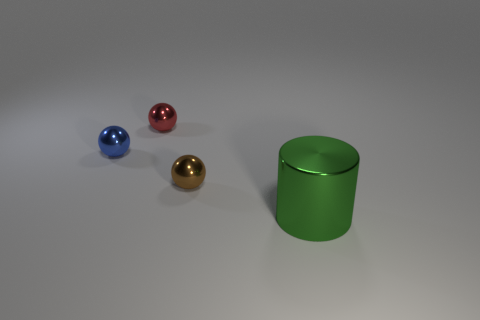What number of tiny shiny things are on the left side of the small shiny ball in front of the tiny blue ball?
Offer a terse response. 2. Are there fewer tiny brown metal objects that are in front of the tiny blue metallic object than tiny red objects that are left of the green cylinder?
Make the answer very short. No. What is the tiny ball that is right of the small red object made of?
Keep it short and to the point. Metal. The tiny sphere that is both on the right side of the tiny blue object and behind the brown object is what color?
Offer a very short reply. Red. What number of other things are the same color as the metallic cylinder?
Provide a succinct answer. 0. There is a thing to the right of the brown thing; what is its color?
Give a very brief answer. Green. Is there another red thing of the same size as the red thing?
Your answer should be very brief. No. What number of objects are small balls that are to the left of the small red metal sphere or things to the left of the shiny cylinder?
Keep it short and to the point. 3. Are there any other tiny shiny things that have the same shape as the brown metal thing?
Keep it short and to the point. Yes. How many rubber objects are big cyan things or tiny red spheres?
Provide a short and direct response. 0. 